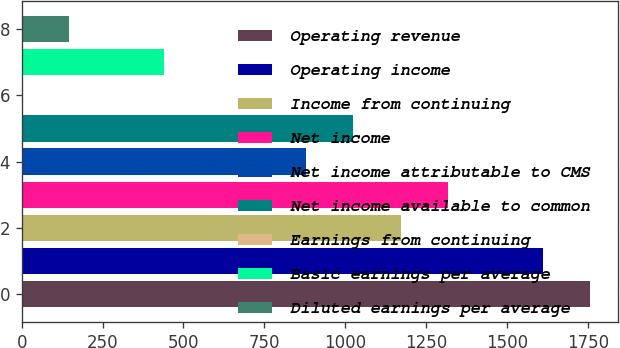Convert chart. <chart><loc_0><loc_0><loc_500><loc_500><bar_chart><fcel>Operating revenue<fcel>Operating income<fcel>Income from continuing<fcel>Net income<fcel>Net income attributable to CMS<fcel>Net income available to common<fcel>Earnings from continuing<fcel>Basic earnings per average<fcel>Diluted earnings per average<nl><fcel>1756.73<fcel>1610.38<fcel>1171.33<fcel>1317.68<fcel>878.63<fcel>1024.98<fcel>0.53<fcel>439.58<fcel>146.88<nl></chart> 